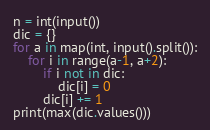Convert code to text. <code><loc_0><loc_0><loc_500><loc_500><_Python_>n = int(input())
dic = {}
for a in map(int, input().split()):
    for i in range(a-1, a+2):
        if i not in dic:
            dic[i] = 0
        dic[i] += 1
print(max(dic.values()))</code> 